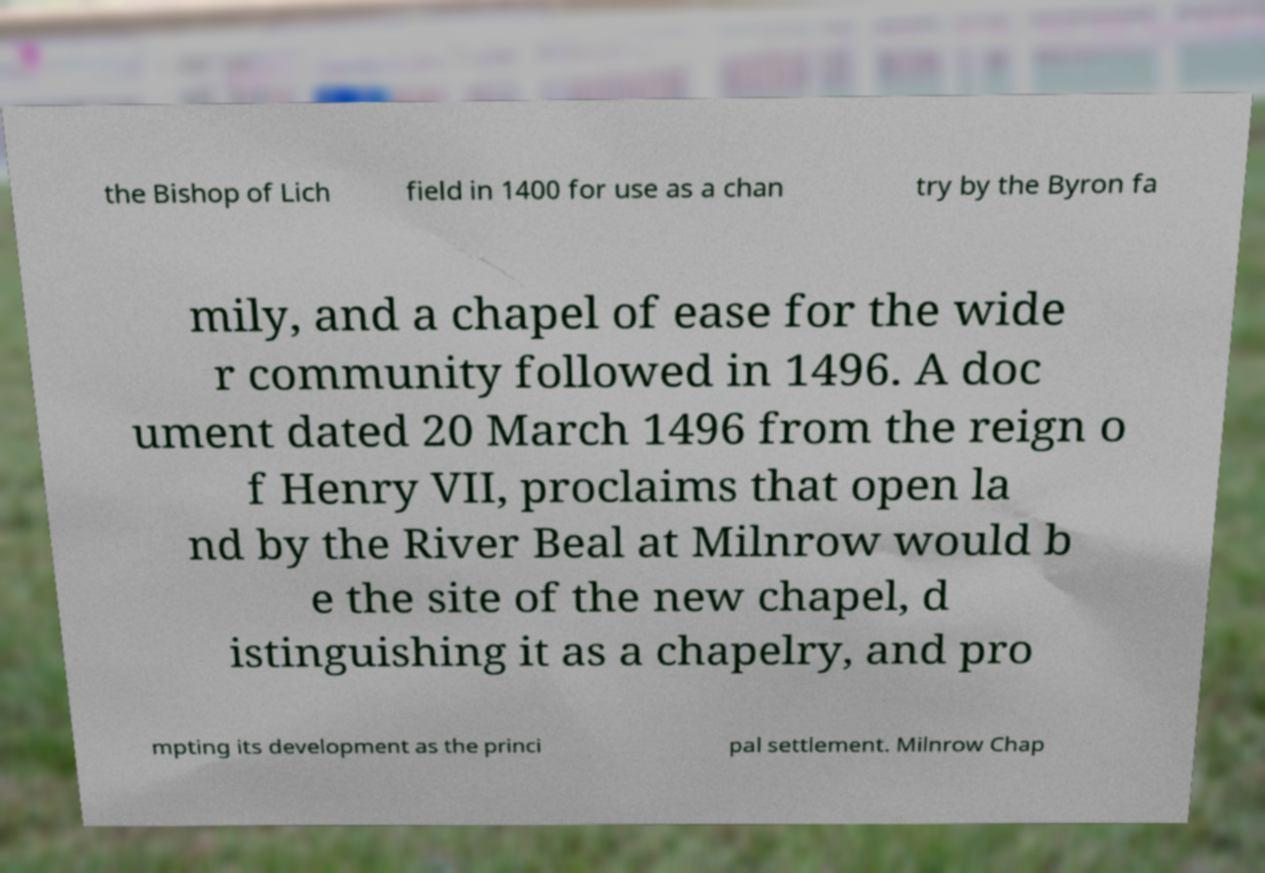Please read and relay the text visible in this image. What does it say? the Bishop of Lich field in 1400 for use as a chan try by the Byron fa mily, and a chapel of ease for the wide r community followed in 1496. A doc ument dated 20 March 1496 from the reign o f Henry VII, proclaims that open la nd by the River Beal at Milnrow would b e the site of the new chapel, d istinguishing it as a chapelry, and pro mpting its development as the princi pal settlement. Milnrow Chap 